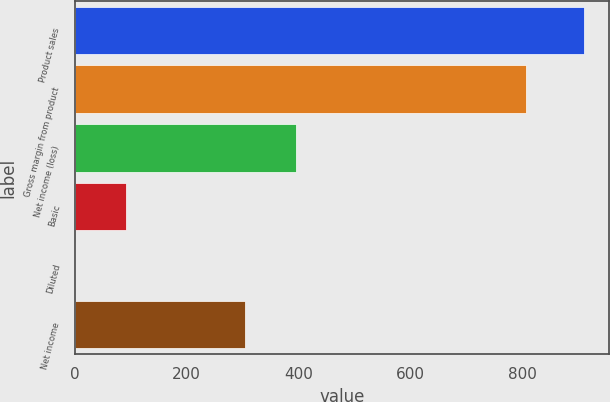<chart> <loc_0><loc_0><loc_500><loc_500><bar_chart><fcel>Product sales<fcel>Gross margin from product<fcel>Net income (loss)<fcel>Basic<fcel>Diluted<fcel>Net income<nl><fcel>908.6<fcel>805<fcel>395.73<fcel>91.15<fcel>0.32<fcel>304.9<nl></chart> 